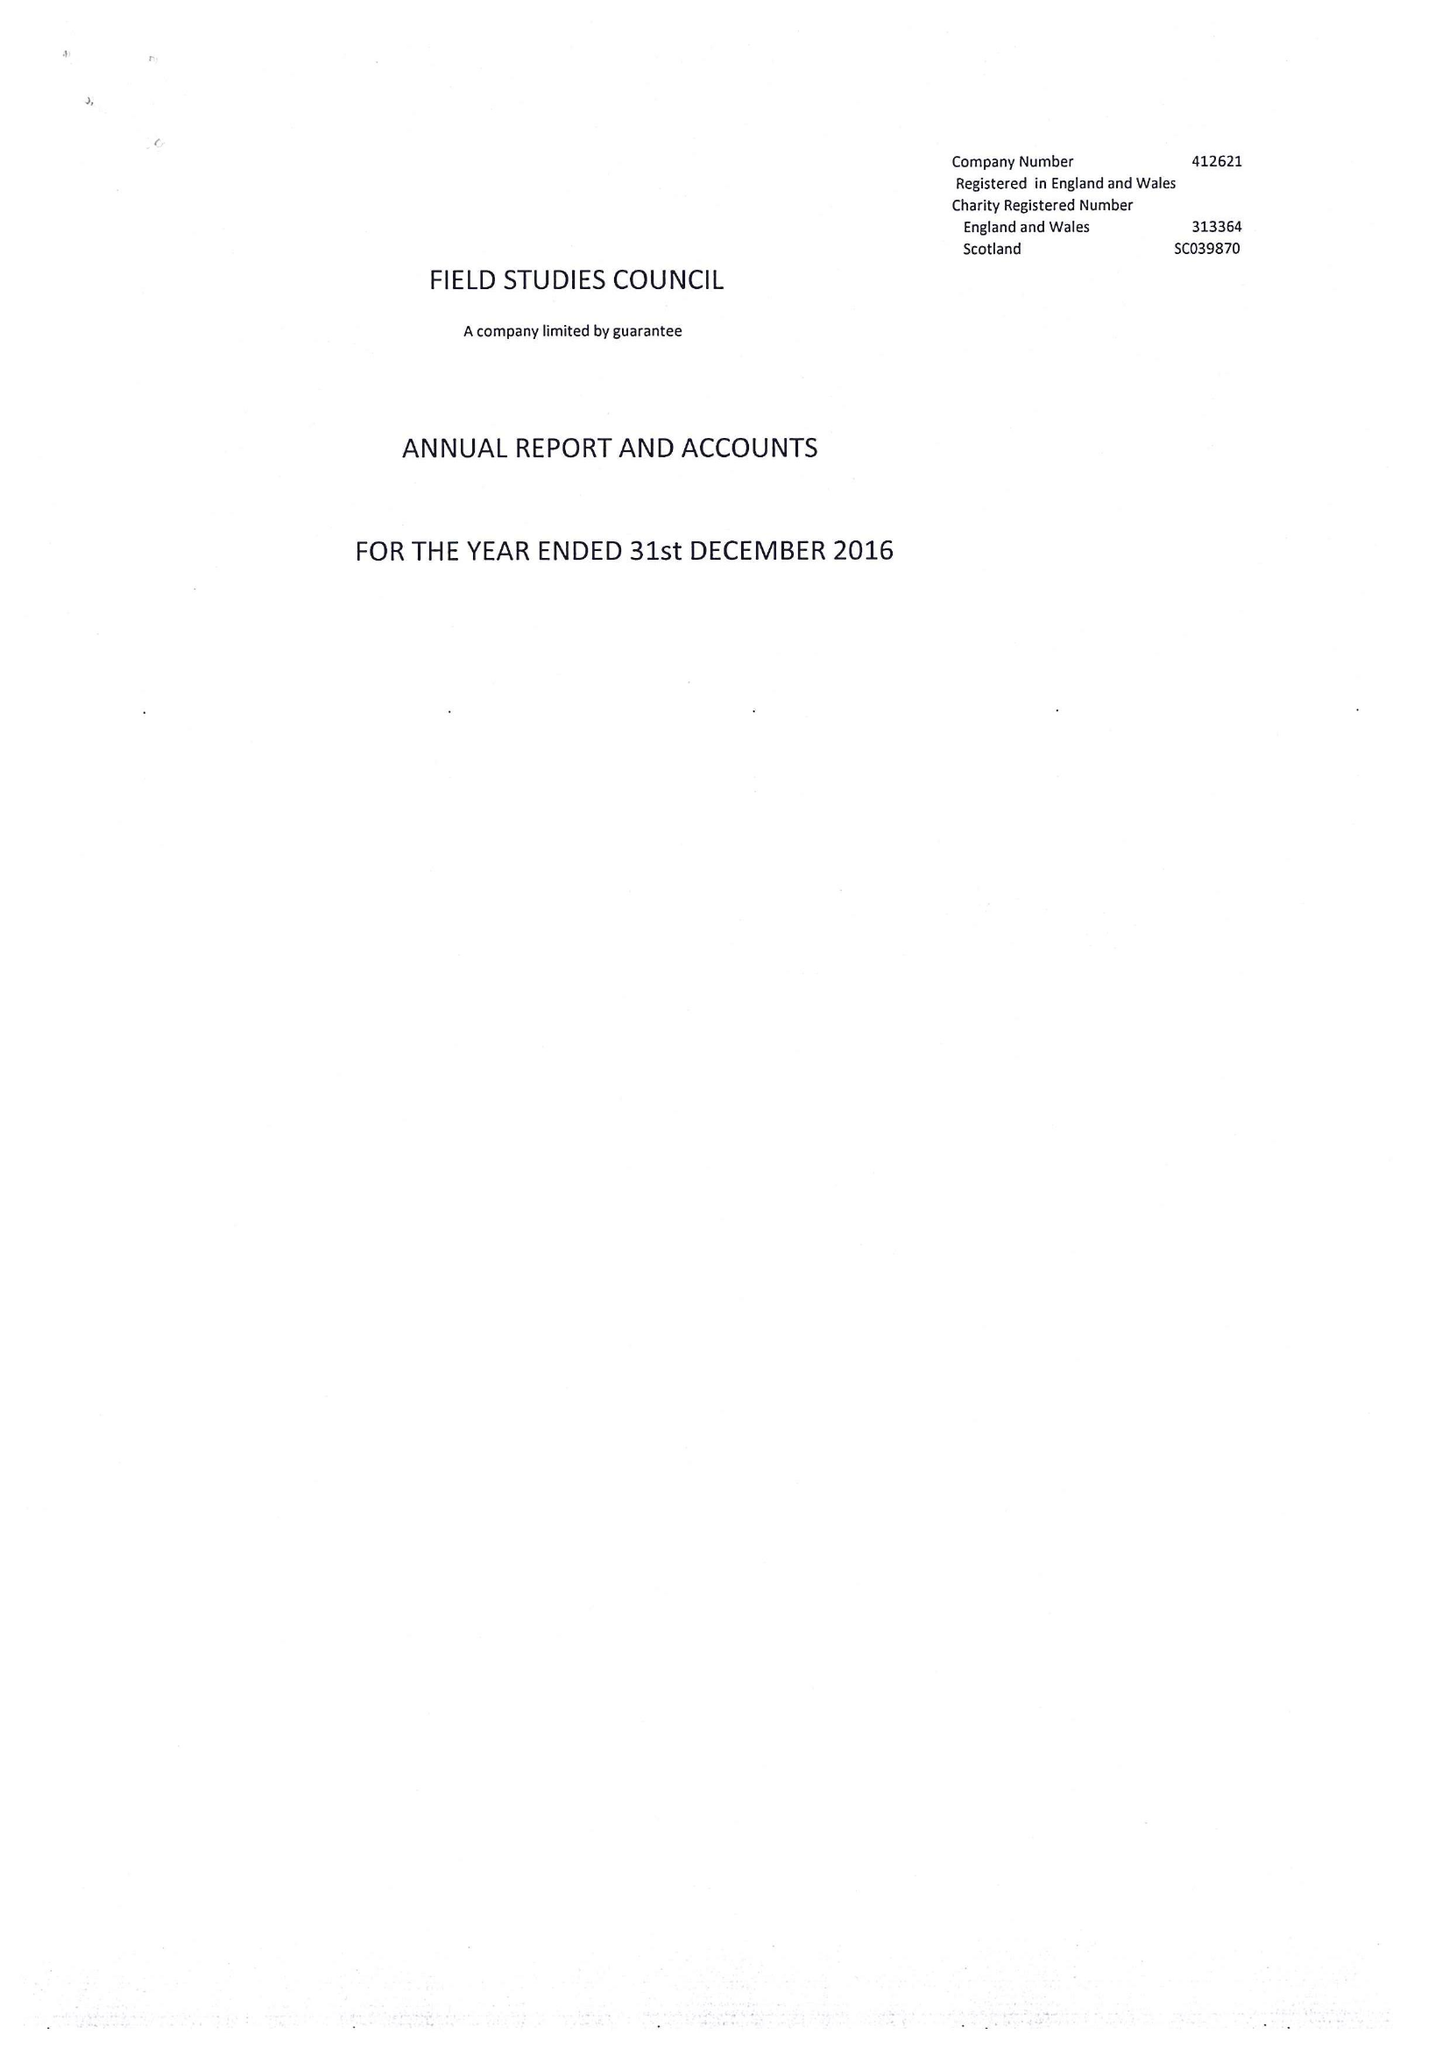What is the value for the report_date?
Answer the question using a single word or phrase. 2016-12-31 